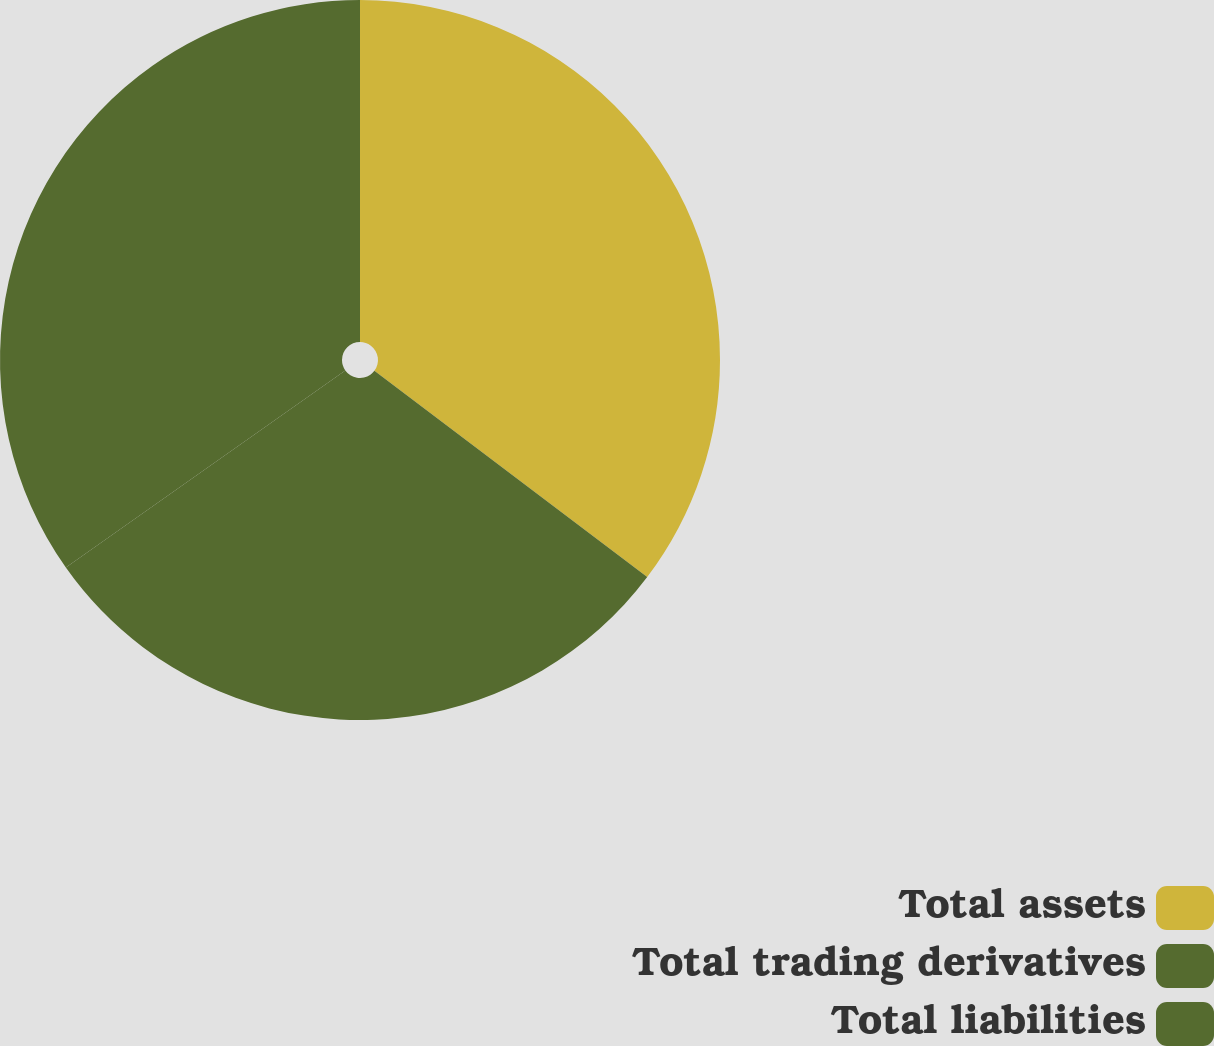Convert chart to OTSL. <chart><loc_0><loc_0><loc_500><loc_500><pie_chart><fcel>Total assets<fcel>Total trading derivatives<fcel>Total liabilities<nl><fcel>35.3%<fcel>29.92%<fcel>34.78%<nl></chart> 